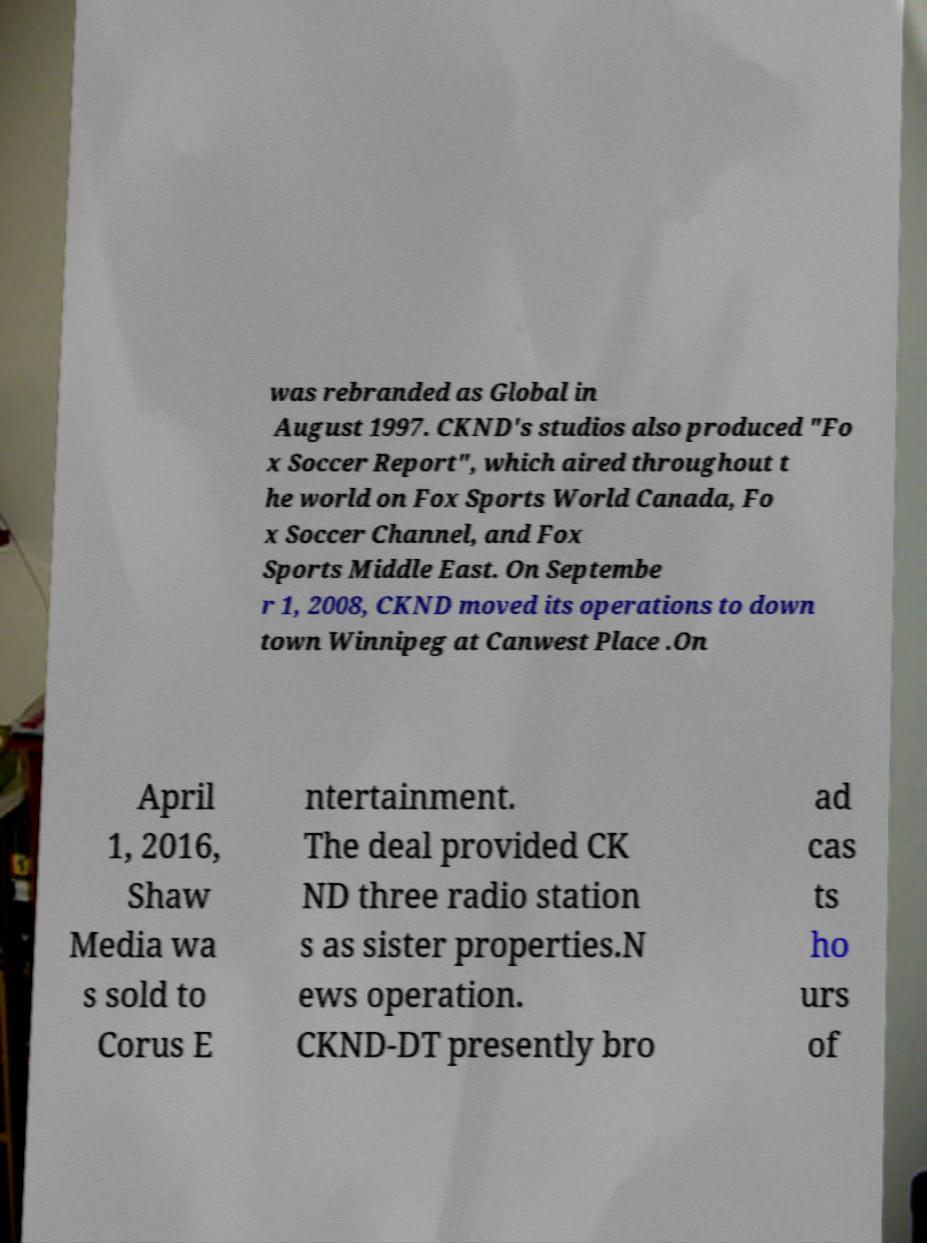I need the written content from this picture converted into text. Can you do that? was rebranded as Global in August 1997. CKND's studios also produced "Fo x Soccer Report", which aired throughout t he world on Fox Sports World Canada, Fo x Soccer Channel, and Fox Sports Middle East. On Septembe r 1, 2008, CKND moved its operations to down town Winnipeg at Canwest Place .On April 1, 2016, Shaw Media wa s sold to Corus E ntertainment. The deal provided CK ND three radio station s as sister properties.N ews operation. CKND-DT presently bro ad cas ts ho urs of 